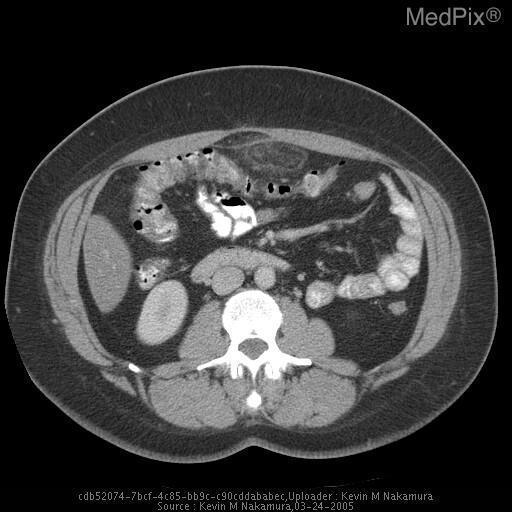How many masses are there?
Give a very brief answer. One. What is the location of the mass
Be succinct. Anterior to the transverse colon. Where is the mass located?
Write a very short answer. Anterior to the transverse colon. Is the peritoneum thickened?
Concise answer only. Yes. Is there thickening of the peritoneum?
Short answer required. Yes. What is the composition of the mass?
Answer briefly. Fat. What is this mass primarily made of?
Quick response, please. Fat. 